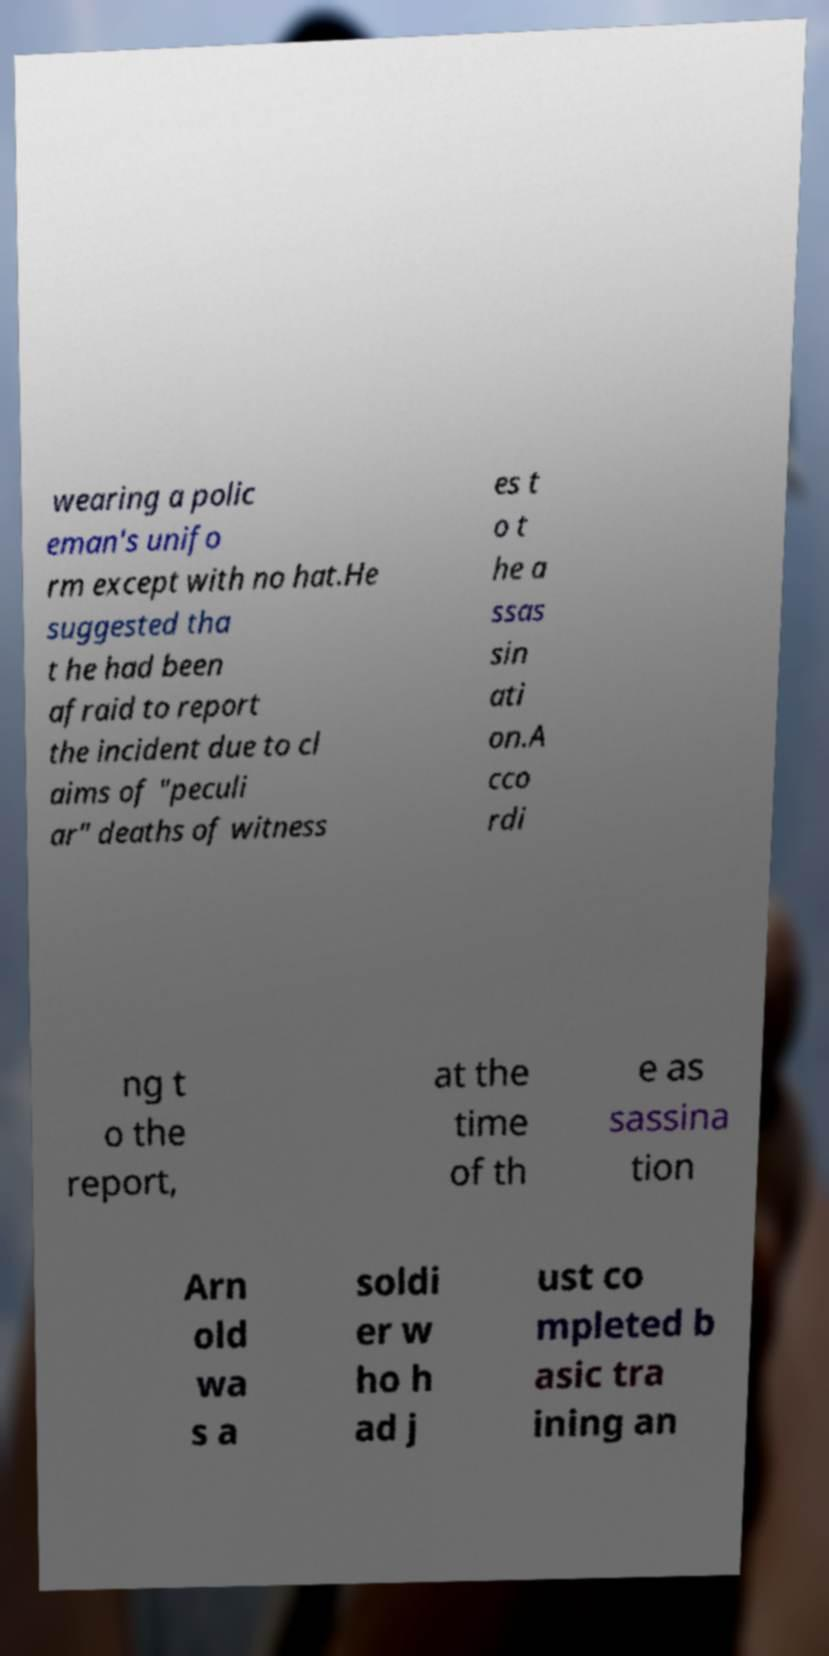For documentation purposes, I need the text within this image transcribed. Could you provide that? wearing a polic eman's unifo rm except with no hat.He suggested tha t he had been afraid to report the incident due to cl aims of "peculi ar" deaths of witness es t o t he a ssas sin ati on.A cco rdi ng t o the report, at the time of th e as sassina tion Arn old wa s a soldi er w ho h ad j ust co mpleted b asic tra ining an 